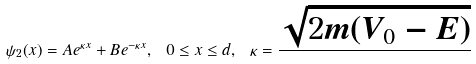<formula> <loc_0><loc_0><loc_500><loc_500>\psi _ { 2 } ( x ) = A e ^ { \kappa x } + B e ^ { - \kappa x } , \ 0 \leq x \leq d , \ \kappa = \frac { \sqrt { 2 m ( V _ { 0 } - E ) } } { }</formula> 